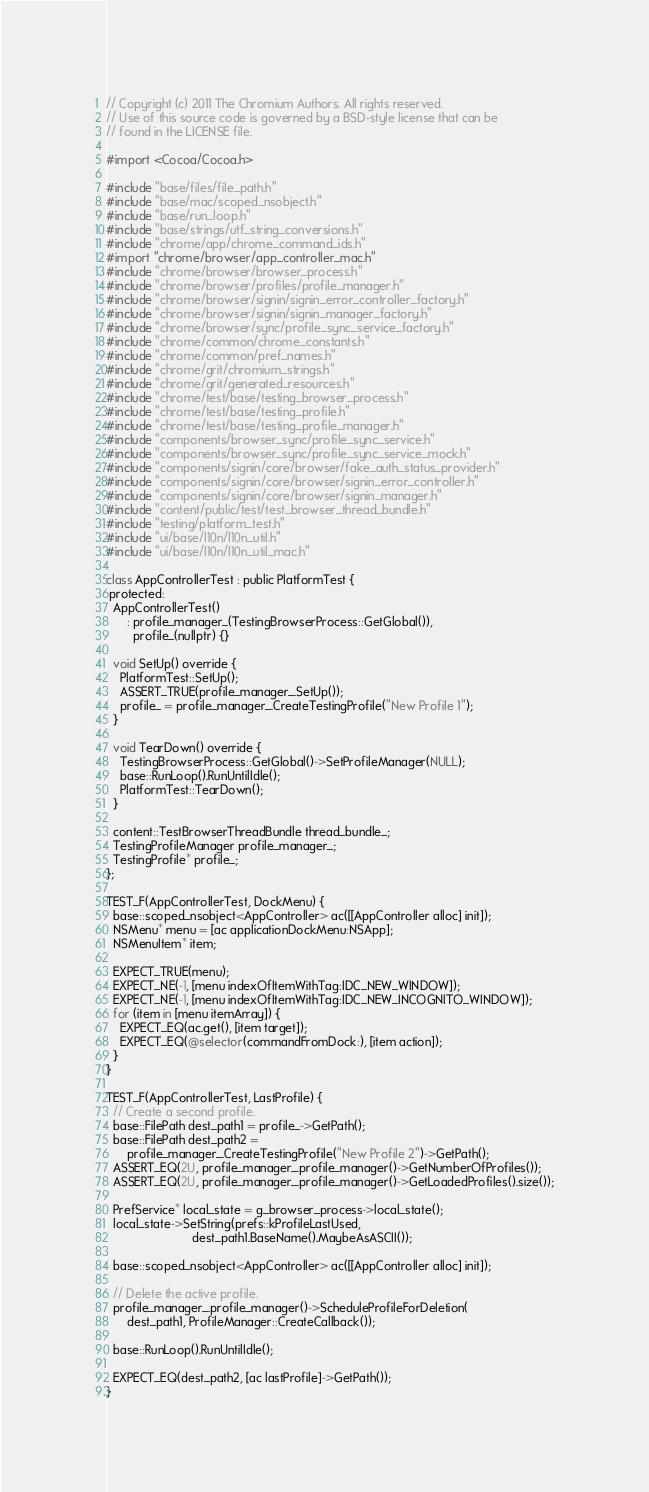<code> <loc_0><loc_0><loc_500><loc_500><_ObjectiveC_>// Copyright (c) 2011 The Chromium Authors. All rights reserved.
// Use of this source code is governed by a BSD-style license that can be
// found in the LICENSE file.

#import <Cocoa/Cocoa.h>

#include "base/files/file_path.h"
#include "base/mac/scoped_nsobject.h"
#include "base/run_loop.h"
#include "base/strings/utf_string_conversions.h"
#include "chrome/app/chrome_command_ids.h"
#import "chrome/browser/app_controller_mac.h"
#include "chrome/browser/browser_process.h"
#include "chrome/browser/profiles/profile_manager.h"
#include "chrome/browser/signin/signin_error_controller_factory.h"
#include "chrome/browser/signin/signin_manager_factory.h"
#include "chrome/browser/sync/profile_sync_service_factory.h"
#include "chrome/common/chrome_constants.h"
#include "chrome/common/pref_names.h"
#include "chrome/grit/chromium_strings.h"
#include "chrome/grit/generated_resources.h"
#include "chrome/test/base/testing_browser_process.h"
#include "chrome/test/base/testing_profile.h"
#include "chrome/test/base/testing_profile_manager.h"
#include "components/browser_sync/profile_sync_service.h"
#include "components/browser_sync/profile_sync_service_mock.h"
#include "components/signin/core/browser/fake_auth_status_provider.h"
#include "components/signin/core/browser/signin_error_controller.h"
#include "components/signin/core/browser/signin_manager.h"
#include "content/public/test/test_browser_thread_bundle.h"
#include "testing/platform_test.h"
#include "ui/base/l10n/l10n_util.h"
#include "ui/base/l10n/l10n_util_mac.h"

class AppControllerTest : public PlatformTest {
 protected:
  AppControllerTest()
      : profile_manager_(TestingBrowserProcess::GetGlobal()),
        profile_(nullptr) {}

  void SetUp() override {
    PlatformTest::SetUp();
    ASSERT_TRUE(profile_manager_.SetUp());
    profile_ = profile_manager_.CreateTestingProfile("New Profile 1");
  }

  void TearDown() override {
    TestingBrowserProcess::GetGlobal()->SetProfileManager(NULL);
    base::RunLoop().RunUntilIdle();
    PlatformTest::TearDown();
  }

  content::TestBrowserThreadBundle thread_bundle_;
  TestingProfileManager profile_manager_;
  TestingProfile* profile_;
};

TEST_F(AppControllerTest, DockMenu) {
  base::scoped_nsobject<AppController> ac([[AppController alloc] init]);
  NSMenu* menu = [ac applicationDockMenu:NSApp];
  NSMenuItem* item;

  EXPECT_TRUE(menu);
  EXPECT_NE(-1, [menu indexOfItemWithTag:IDC_NEW_WINDOW]);
  EXPECT_NE(-1, [menu indexOfItemWithTag:IDC_NEW_INCOGNITO_WINDOW]);
  for (item in [menu itemArray]) {
    EXPECT_EQ(ac.get(), [item target]);
    EXPECT_EQ(@selector(commandFromDock:), [item action]);
  }
}

TEST_F(AppControllerTest, LastProfile) {
  // Create a second profile.
  base::FilePath dest_path1 = profile_->GetPath();
  base::FilePath dest_path2 =
      profile_manager_.CreateTestingProfile("New Profile 2")->GetPath();
  ASSERT_EQ(2U, profile_manager_.profile_manager()->GetNumberOfProfiles());
  ASSERT_EQ(2U, profile_manager_.profile_manager()->GetLoadedProfiles().size());

  PrefService* local_state = g_browser_process->local_state();
  local_state->SetString(prefs::kProfileLastUsed,
                         dest_path1.BaseName().MaybeAsASCII());

  base::scoped_nsobject<AppController> ac([[AppController alloc] init]);

  // Delete the active profile.
  profile_manager_.profile_manager()->ScheduleProfileForDeletion(
      dest_path1, ProfileManager::CreateCallback());

  base::RunLoop().RunUntilIdle();

  EXPECT_EQ(dest_path2, [ac lastProfile]->GetPath());
}
</code> 